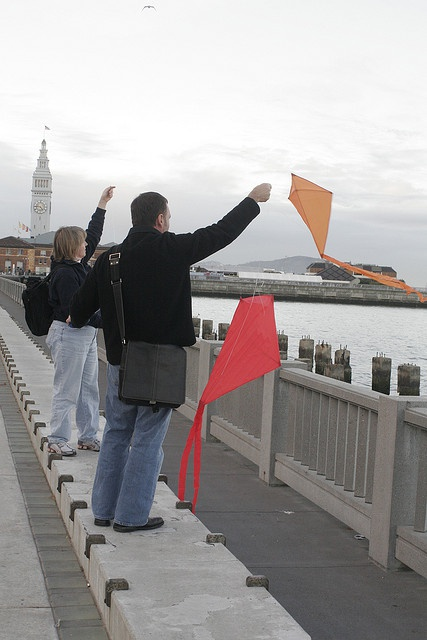Describe the objects in this image and their specific colors. I can see people in white, black, gray, and darkblue tones, people in white, darkgray, black, and gray tones, kite in white and brown tones, handbag in white, black, and gray tones, and kite in white, tan, and salmon tones in this image. 